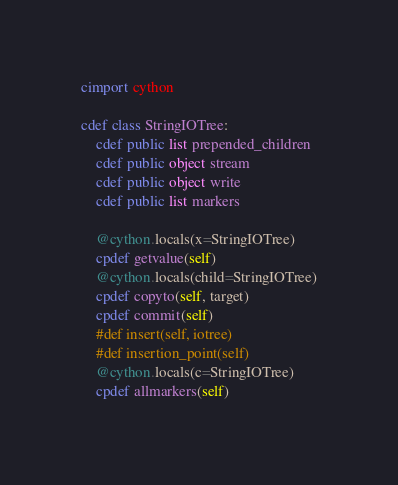Convert code to text. <code><loc_0><loc_0><loc_500><loc_500><_Cython_>cimport cython

cdef class StringIOTree:
    cdef public list prepended_children
    cdef public object stream
    cdef public object write
    cdef public list markers

    @cython.locals(x=StringIOTree)
    cpdef getvalue(self)
    @cython.locals(child=StringIOTree)
    cpdef copyto(self, target)
    cpdef commit(self)
    #def insert(self, iotree)
    #def insertion_point(self)
    @cython.locals(c=StringIOTree)
    cpdef allmarkers(self)
</code> 